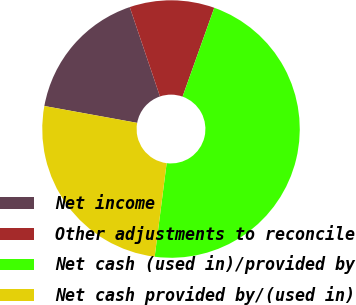Convert chart to OTSL. <chart><loc_0><loc_0><loc_500><loc_500><pie_chart><fcel>Net income<fcel>Other adjustments to reconcile<fcel>Net cash (used in)/provided by<fcel>Net cash provided by/(used in)<nl><fcel>16.94%<fcel>10.65%<fcel>46.57%<fcel>25.84%<nl></chart> 